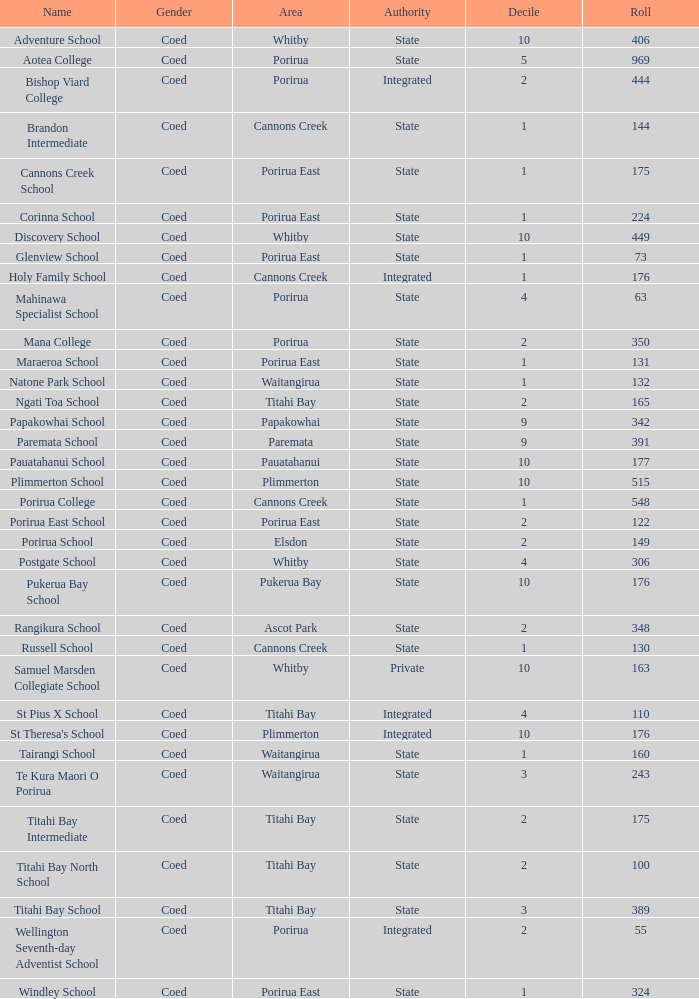What is the roll of Bishop Viard College (An Integrated College), which has a decile larger than 1? 1.0. 